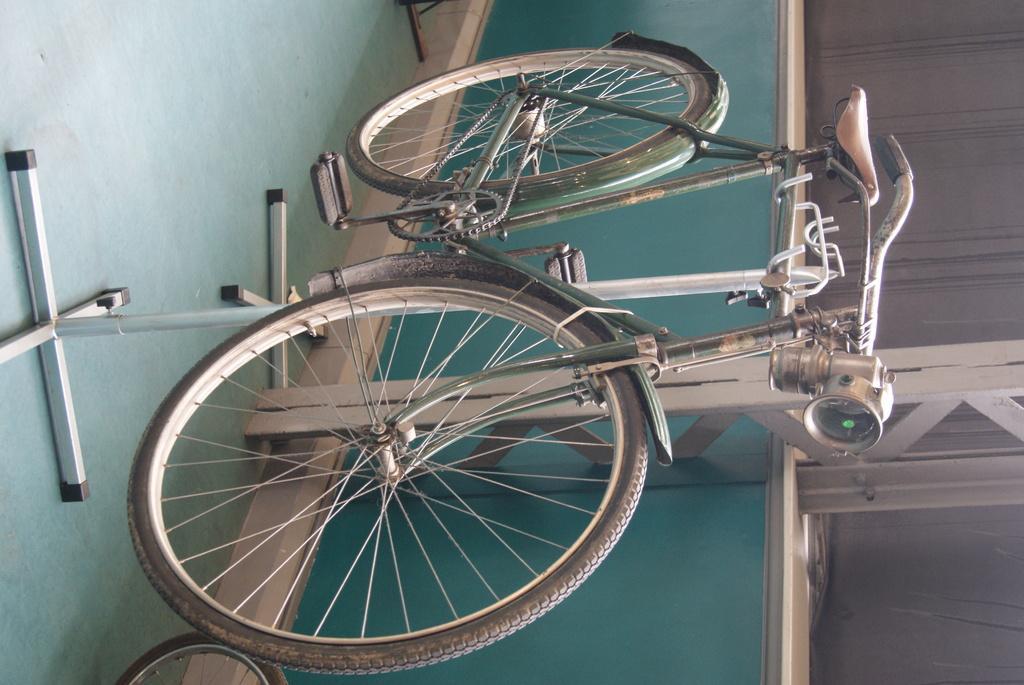Describe this image in one or two sentences. In this image we can see a bicycle on a stand. Behind the bicycle we can see a wall. At the bottom we can see a wheel. 